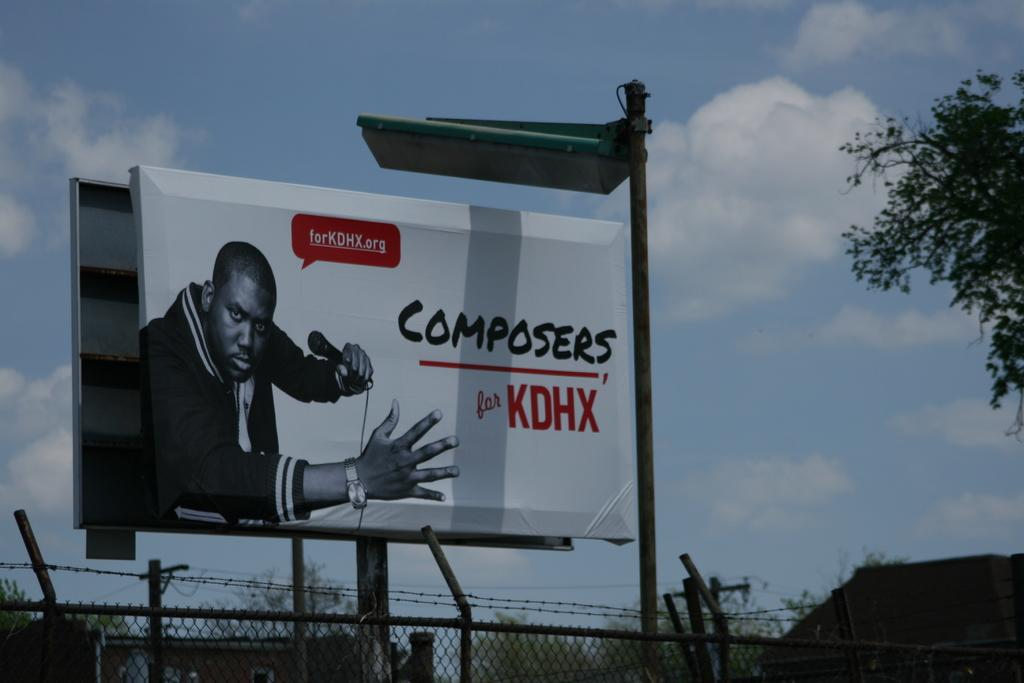<image>
Share a concise interpretation of the image provided. A billboard for KDHX composers has a black man holding a microphone on it. 